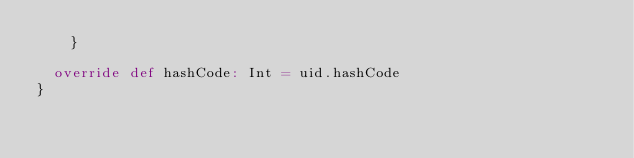Convert code to text. <code><loc_0><loc_0><loc_500><loc_500><_Scala_>    }

  override def hashCode: Int = uid.hashCode
}
</code> 